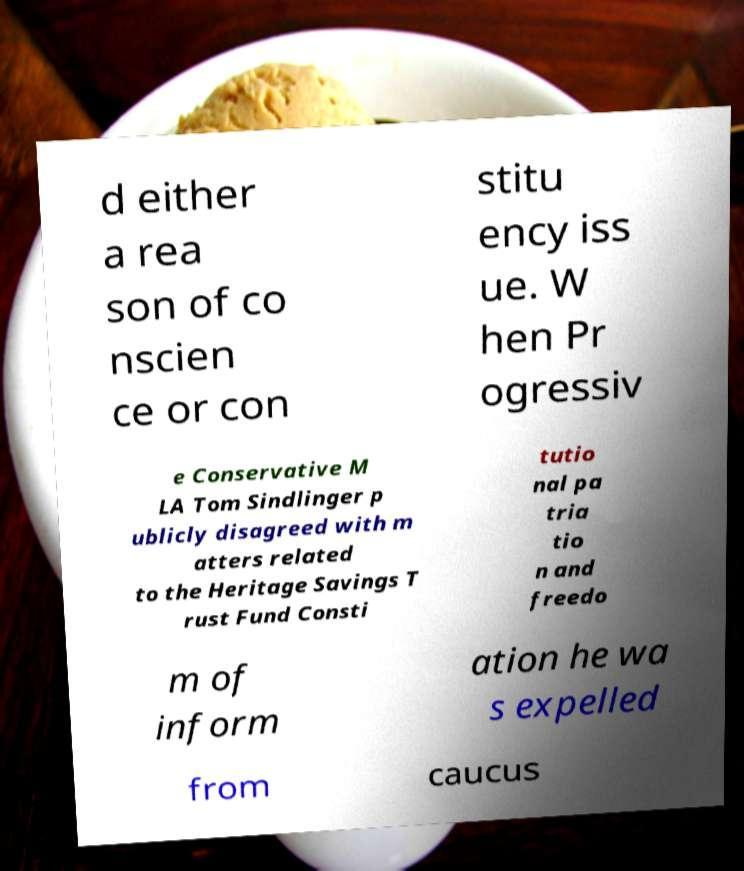There's text embedded in this image that I need extracted. Can you transcribe it verbatim? d either a rea son of co nscien ce or con stitu ency iss ue. W hen Pr ogressiv e Conservative M LA Tom Sindlinger p ublicly disagreed with m atters related to the Heritage Savings T rust Fund Consti tutio nal pa tria tio n and freedo m of inform ation he wa s expelled from caucus 